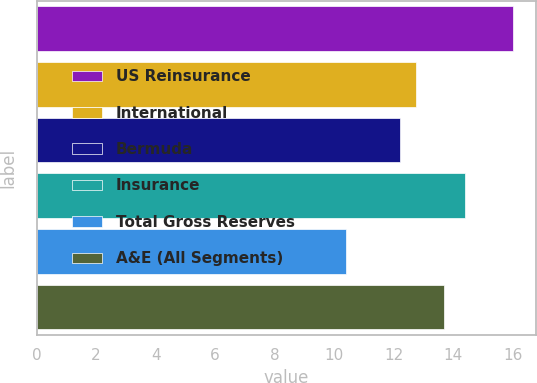Convert chart. <chart><loc_0><loc_0><loc_500><loc_500><bar_chart><fcel>US Reinsurance<fcel>International<fcel>Bermuda<fcel>Insurance<fcel>Total Gross Reserves<fcel>A&E (All Segments)<nl><fcel>16<fcel>12.76<fcel>12.2<fcel>14.4<fcel>10.4<fcel>13.7<nl></chart> 